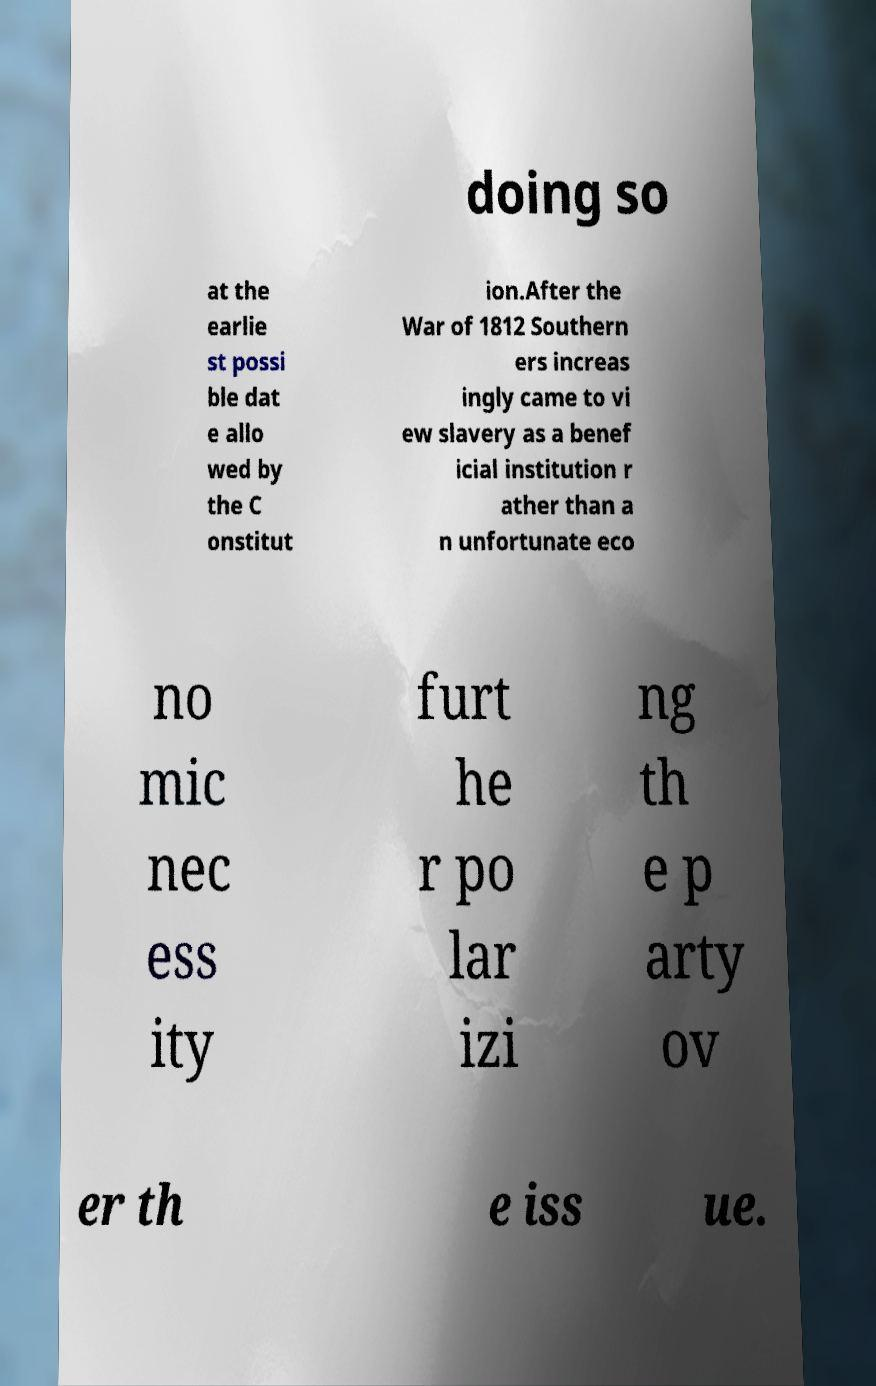What messages or text are displayed in this image? I need them in a readable, typed format. doing so at the earlie st possi ble dat e allo wed by the C onstitut ion.After the War of 1812 Southern ers increas ingly came to vi ew slavery as a benef icial institution r ather than a n unfortunate eco no mic nec ess ity furt he r po lar izi ng th e p arty ov er th e iss ue. 